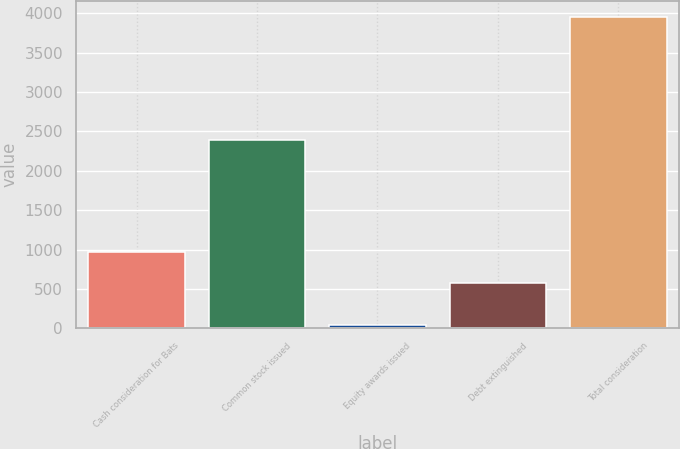<chart> <loc_0><loc_0><loc_500><loc_500><bar_chart><fcel>Cash consideration for Bats<fcel>Common stock issued<fcel>Equity awards issued<fcel>Debt extinguished<fcel>Total consideration<nl><fcel>972.28<fcel>2387.3<fcel>37.4<fcel>580<fcel>3960.2<nl></chart> 